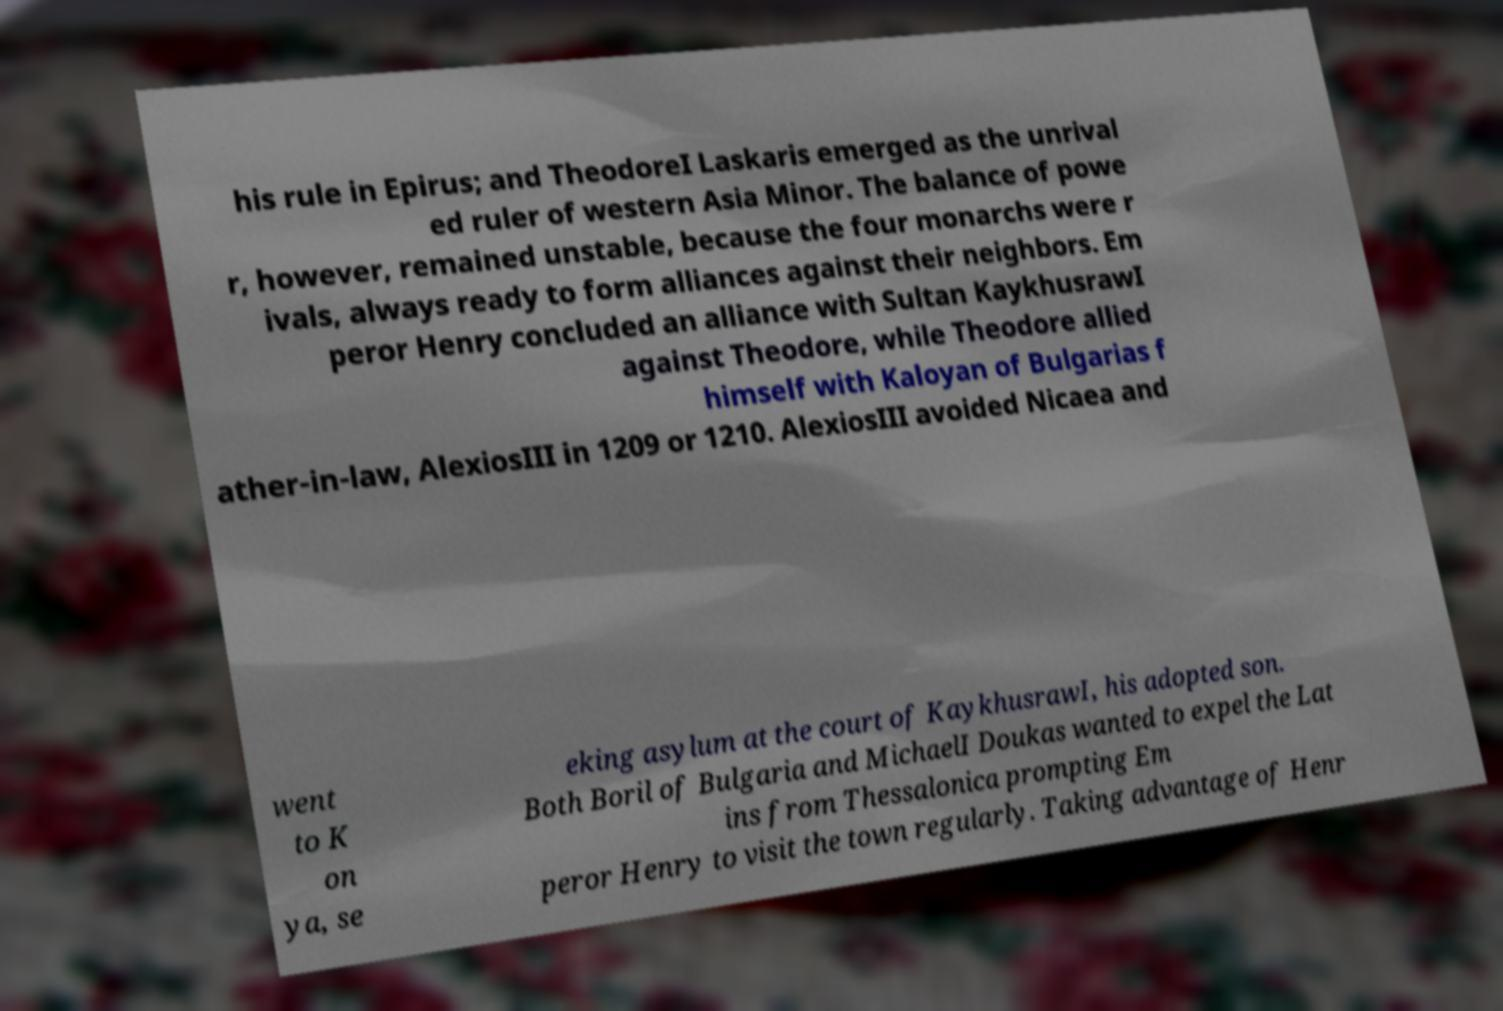Can you read and provide the text displayed in the image?This photo seems to have some interesting text. Can you extract and type it out for me? his rule in Epirus; and TheodoreI Laskaris emerged as the unrival ed ruler of western Asia Minor. The balance of powe r, however, remained unstable, because the four monarchs were r ivals, always ready to form alliances against their neighbors. Em peror Henry concluded an alliance with Sultan KaykhusrawI against Theodore, while Theodore allied himself with Kaloyan of Bulgarias f ather-in-law, AlexiosIII in 1209 or 1210. AlexiosIII avoided Nicaea and went to K on ya, se eking asylum at the court of KaykhusrawI, his adopted son. Both Boril of Bulgaria and MichaelI Doukas wanted to expel the Lat ins from Thessalonica prompting Em peror Henry to visit the town regularly. Taking advantage of Henr 